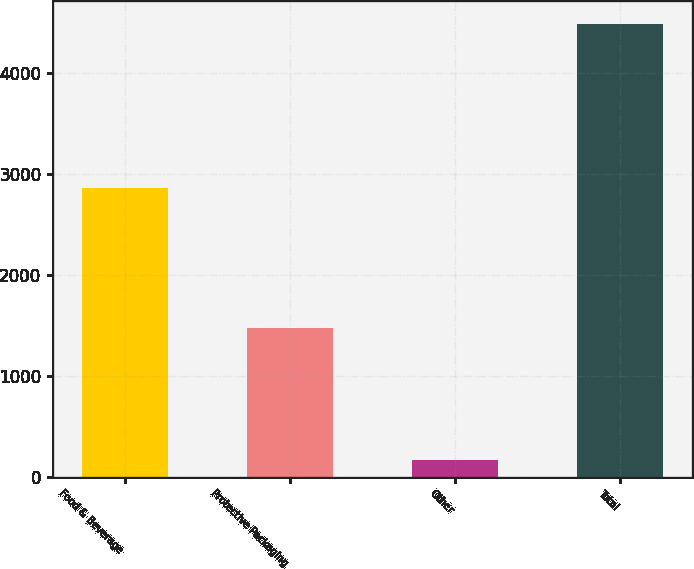Convert chart. <chart><loc_0><loc_0><loc_500><loc_500><bar_chart><fcel>Food & Beverage<fcel>Protective Packaging<fcel>Other<fcel>Total<nl><fcel>2858.5<fcel>1469.9<fcel>161.7<fcel>4490.1<nl></chart> 